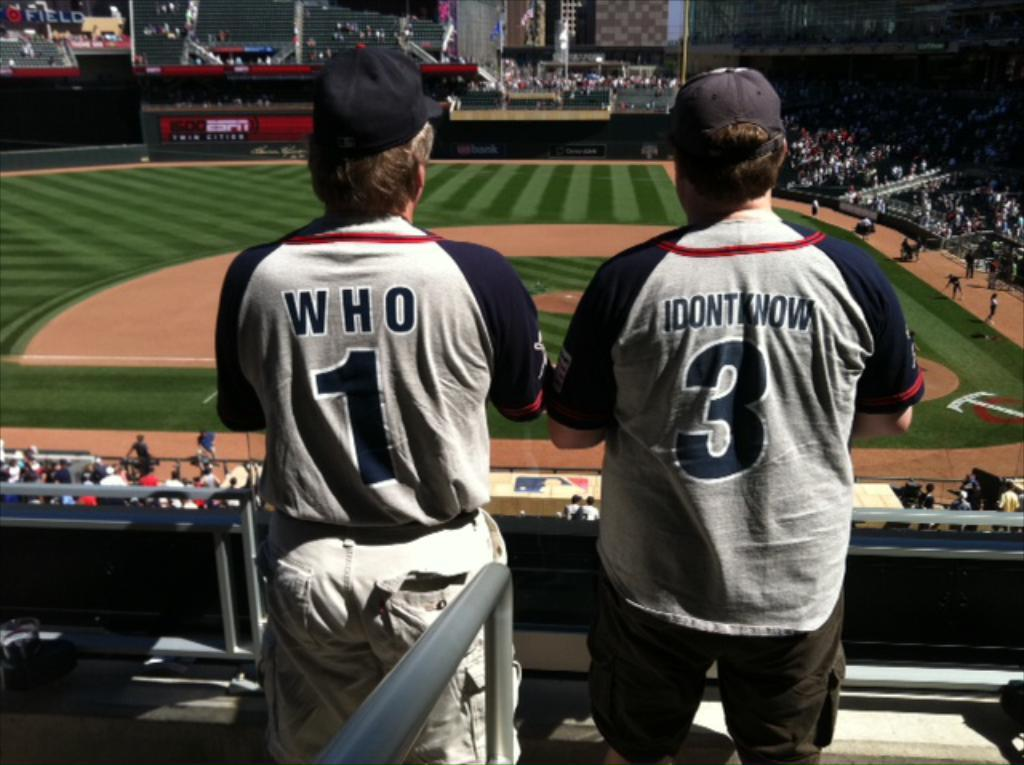Provide a one-sentence caption for the provided image. two people in jerseys reading Who and I Don't Know watch a baseball game. 